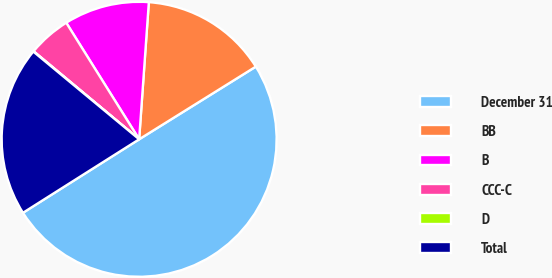Convert chart. <chart><loc_0><loc_0><loc_500><loc_500><pie_chart><fcel>December 31<fcel>BB<fcel>B<fcel>CCC-C<fcel>D<fcel>Total<nl><fcel>49.89%<fcel>15.01%<fcel>10.02%<fcel>5.04%<fcel>0.05%<fcel>19.99%<nl></chart> 